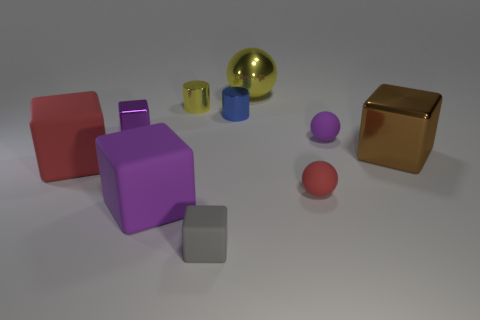Subtract all small gray rubber blocks. How many blocks are left? 4 Subtract all brown spheres. How many purple blocks are left? 2 Subtract 1 balls. How many balls are left? 2 Subtract all brown cubes. How many cubes are left? 4 Subtract all balls. How many objects are left? 7 Subtract all yellow blocks. Subtract all blue cylinders. How many blocks are left? 5 Add 4 gray matte blocks. How many gray matte blocks exist? 5 Subtract 0 gray spheres. How many objects are left? 10 Subtract all red rubber cubes. Subtract all small yellow cylinders. How many objects are left? 8 Add 9 purple rubber spheres. How many purple rubber spheres are left? 10 